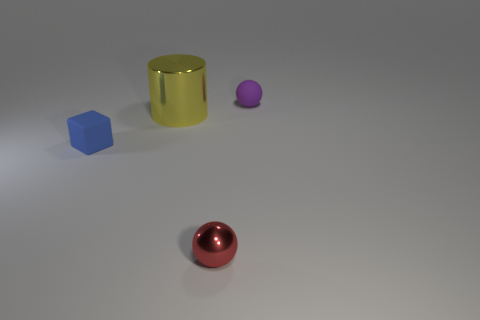What number of cylinders are large yellow objects or small red objects?
Keep it short and to the point. 1. What number of purple shiny spheres are the same size as the cube?
Ensure brevity in your answer.  0. What number of metallic things are in front of the tiny matte thing that is in front of the purple thing?
Offer a terse response. 1. How big is the thing that is both in front of the big yellow metal object and behind the red ball?
Offer a terse response. Small. Is the number of yellow metal things greater than the number of small objects?
Ensure brevity in your answer.  No. Are there any metal spheres that have the same color as the tiny metal thing?
Offer a very short reply. No. There is a rubber object that is to the right of the metallic cylinder; does it have the same size as the big object?
Provide a short and direct response. No. Is the number of small purple matte objects less than the number of small blue cylinders?
Provide a short and direct response. No. Are there any tiny purple spheres made of the same material as the large object?
Ensure brevity in your answer.  No. The tiny rubber object that is to the right of the blue matte block has what shape?
Offer a terse response. Sphere. 